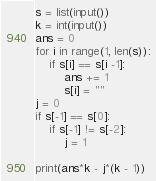Convert code to text. <code><loc_0><loc_0><loc_500><loc_500><_Python_>s = list(input())
k = int(input())
ans = 0
for i in range(1, len(s)):
    if s[i] == s[i -1]:
        ans += 1
        s[i] = ""
j = 0
if s[-1] == s[0]:
    if s[-1] != s[-2]:
        j = 1

print(ans*k - j*(k - 1))</code> 